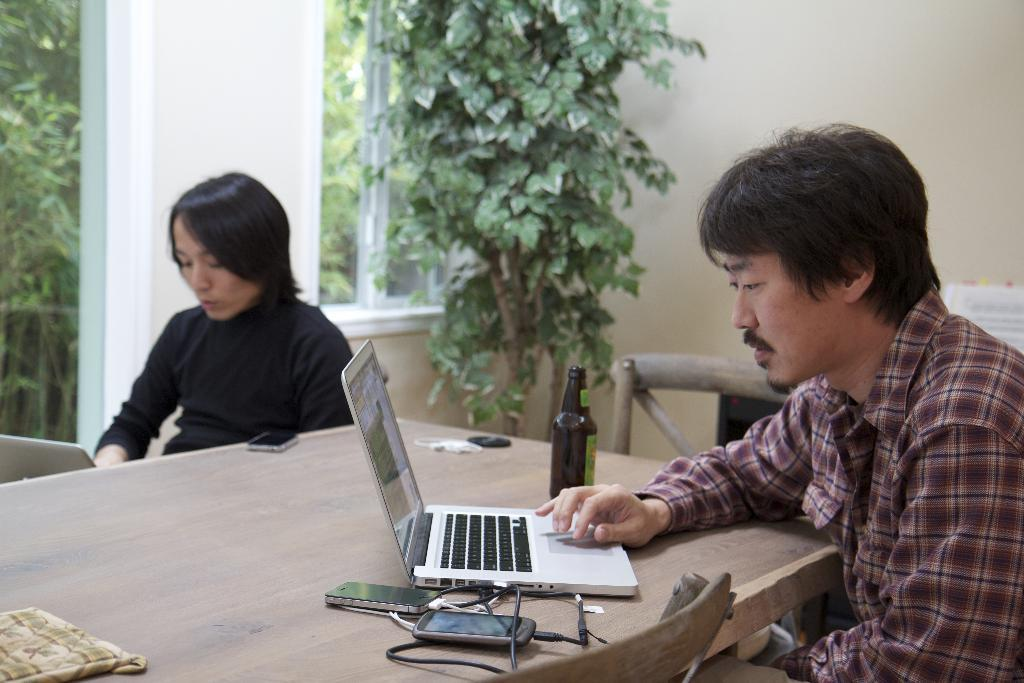How many persons are sitting in the image? There are two persons sitting in the image. What is on the table in the image? A laptop, a mobile phone, a cable, and a bottle are present on the table in the image. What can be seen in the background of the image? There is a wall, a plant, trees, and a window visible in the background. What type of furniture is in the image? Chairs are in the image. What type of hill can be seen in the image? There is no hill present in the image. Is there a jail visible in the image? There is no jail present in the image. 